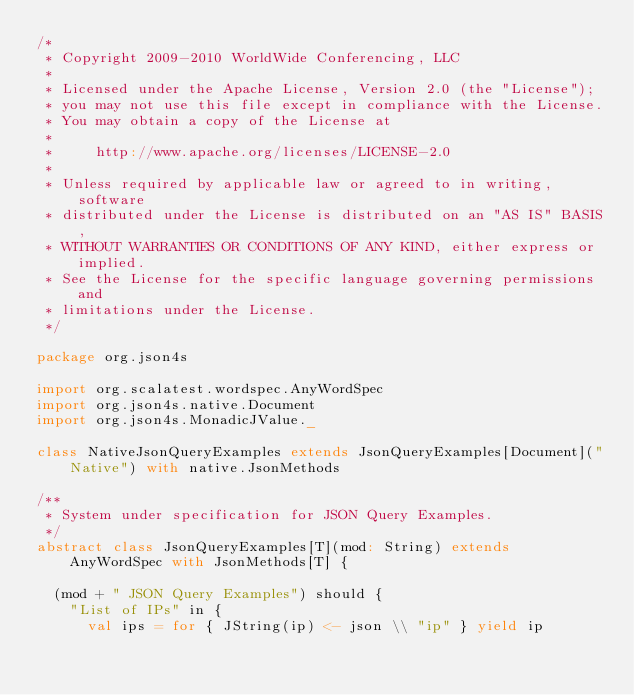Convert code to text. <code><loc_0><loc_0><loc_500><loc_500><_Scala_>/*
 * Copyright 2009-2010 WorldWide Conferencing, LLC
 *
 * Licensed under the Apache License, Version 2.0 (the "License");
 * you may not use this file except in compliance with the License.
 * You may obtain a copy of the License at
 *
 *     http://www.apache.org/licenses/LICENSE-2.0
 *
 * Unless required by applicable law or agreed to in writing, software
 * distributed under the License is distributed on an "AS IS" BASIS,
 * WITHOUT WARRANTIES OR CONDITIONS OF ANY KIND, either express or implied.
 * See the License for the specific language governing permissions and
 * limitations under the License.
 */

package org.json4s

import org.scalatest.wordspec.AnyWordSpec
import org.json4s.native.Document
import org.json4s.MonadicJValue._

class NativeJsonQueryExamples extends JsonQueryExamples[Document]("Native") with native.JsonMethods

/**
 * System under specification for JSON Query Examples.
 */
abstract class JsonQueryExamples[T](mod: String) extends AnyWordSpec with JsonMethods[T] {

  (mod + " JSON Query Examples") should {
    "List of IPs" in {
      val ips = for { JString(ip) <- json \\ "ip" } yield ip</code> 